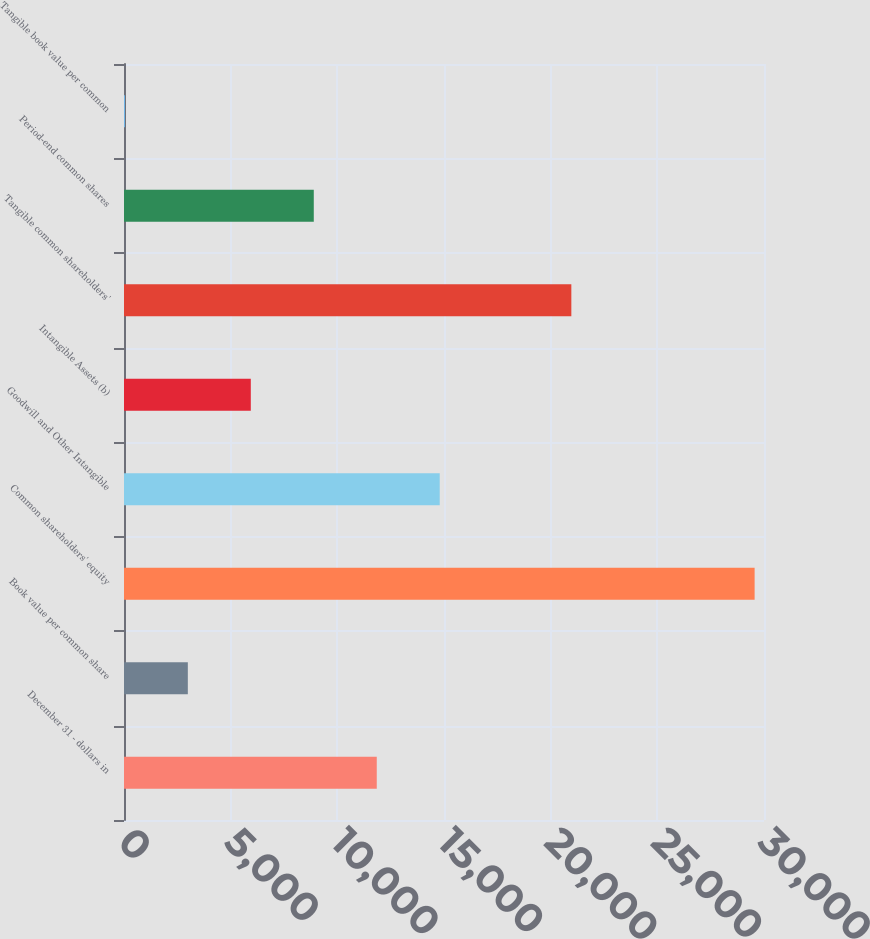Convert chart to OTSL. <chart><loc_0><loc_0><loc_500><loc_500><bar_chart><fcel>December 31 - dollars in<fcel>Book value per common share<fcel>Common shareholders' equity<fcel>Goodwill and Other Intangible<fcel>Intangible Assets (b)<fcel>Tangible common shareholders'<fcel>Period-end common shares<fcel>Tangible book value per common<nl><fcel>11847.9<fcel>2991.89<fcel>29560<fcel>14799.9<fcel>5943.9<fcel>20969<fcel>8895.91<fcel>39.88<nl></chart> 